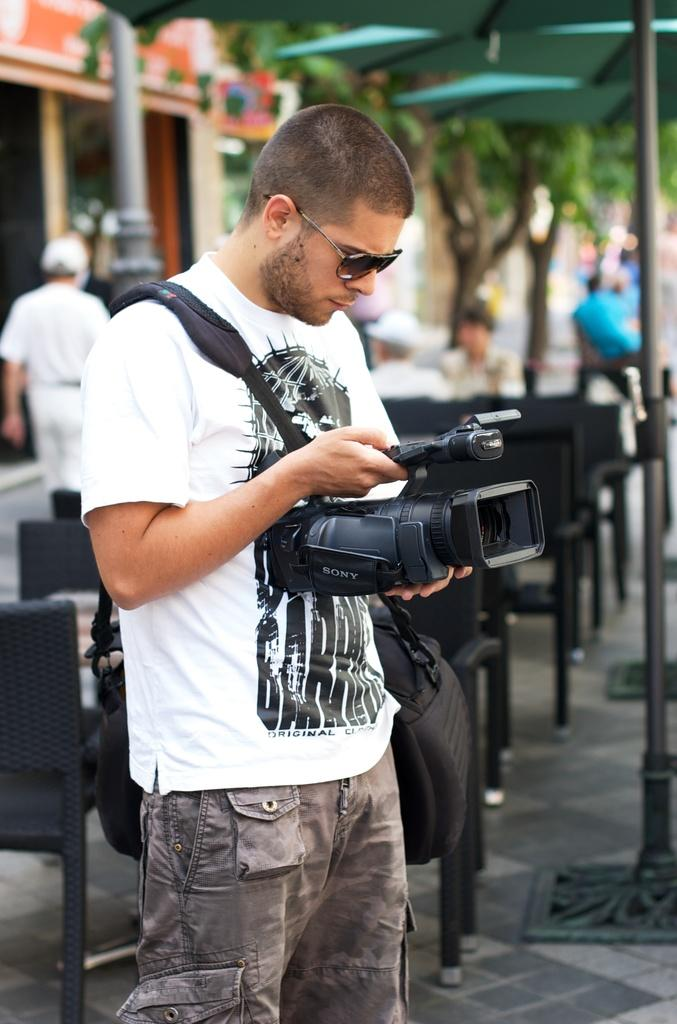What is the main subject of the image? There is a man standing in the center of the image. What is the man holding in his hand? The man is holding a camera in his hand. What is the man doing with the camera? The man is recording something. What can be seen in the background of the image? There is a man walking in the background of the image, and trees are visible as well. What time of day is it in the image, given the presence of the mailbox? There is no mailbox present in the image, so it is not possible to determine the time of day based on that object. 